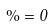<formula> <loc_0><loc_0><loc_500><loc_500>\% = 0</formula> 